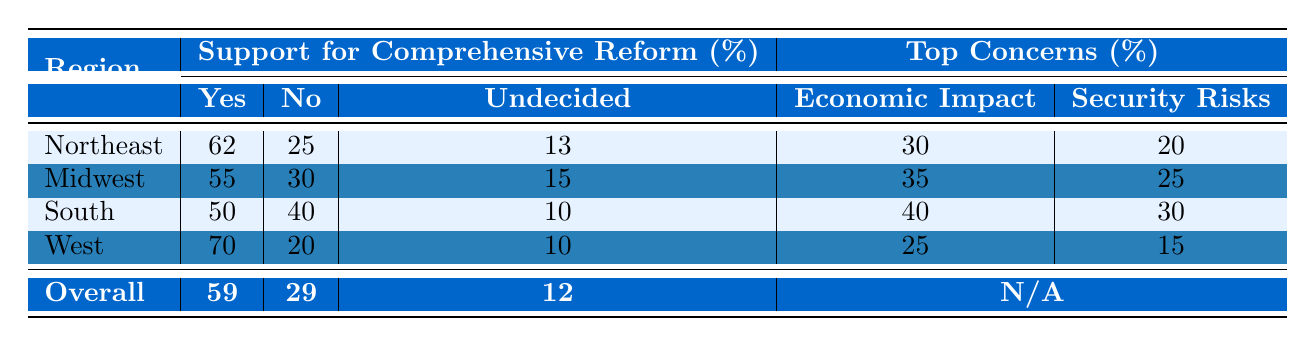What percentage of respondents in the Northeast support comprehensive immigration reform? In the table, under the "Northeast" row and the "Support for Comprehensive Reform" column, the "Yes" value is 62%. This indicates that 62% of respondents in the Northeast support comprehensive immigration reform.
Answer: 62% What is the percentage of respondents in the Midwest who are undecided about comprehensive immigration reform? In the table, under the "Midwest" row, the "Undecided" column shows a value of 15%. This indicates that 15% of respondents in the Midwest are undecided regarding comprehensive immigration reform.
Answer: 15% Which region has the highest percentage of support for comprehensive immigration reform? By comparing the "Yes" values across all regions, we see that the West has the highest value at 70%. Thus, the West has the highest percentage of support for comprehensive immigration reform.
Answer: West What percentage of respondents in the South have concerns about the economic impact of immigration reform? In the "South" row, the "Economic Impact" column shows a value of 40%. This indicates that 40% of respondents in the South have concerns regarding the economic impact of immigration reform.
Answer: 40% If we combine the "No" and "Undecided" responses from the Northeast, what is the total percentage? The "No" column for the Northeast shows 25% and the "Undecided" column shows 13%. Adding these values together gives us 25 + 13 = 38%. Therefore, the total percentage of "No" and "Undecided" responses from the Northeast is 38%.
Answer: 38% In the Midwest, what is the difference in percentage between those who support comprehensive reform and those who do not? The Midwest has 55% supporting and 30% opposing comprehensive immigration reform. To find the difference, we subtract the "No" value from the "Yes" value: 55 - 30 = 25%. Thus, the difference is 25%.
Answer: 25% Are more people in the West supportive of comprehensive reform compared to the overall support percentage? The West has 70% support for comprehensive reform, while the overall support is 59%. Since 70% is greater than 59%, more people in the West support comprehensive reform compared to the overall percentage.
Answer: Yes What is the average percentage of support for comprehensive reform across all four regions? To find the average, sum the values of support from each region: 62 (Northeast) + 55 (Midwest) + 50 (South) + 70 (West) = 237. Then, divide by the number of regions, which is 4: 237 / 4 = 59.25%. Thus, the average support is 59.25%.
Answer: 59.25% What are the top two concerns regarding immigration reform in the South? In the South row, the top concerns from the "Concerns" section are Economic Impact (40%) and Security Risks (30%). Therefore, the top two concerns are Economic Impact and Security Risks.
Answer: Economic Impact and Security Risks How many respondents in the Midwest expressed concerns about cultural integration? According to the Midwest row, the value for concerns about cultural integration is 15%. Thus, this percentage indicates that 15% of respondents in the Midwest expressed concerns about cultural integration.
Answer: 15% Is there any region where more than 50% of respondents have no concerns about immigration reform? In the West region, the value for "No Concerns" is 55%, which is greater than 50%. Therefore, the West is the region where more than 50% of respondents have no concerns about immigration reform.
Answer: Yes 